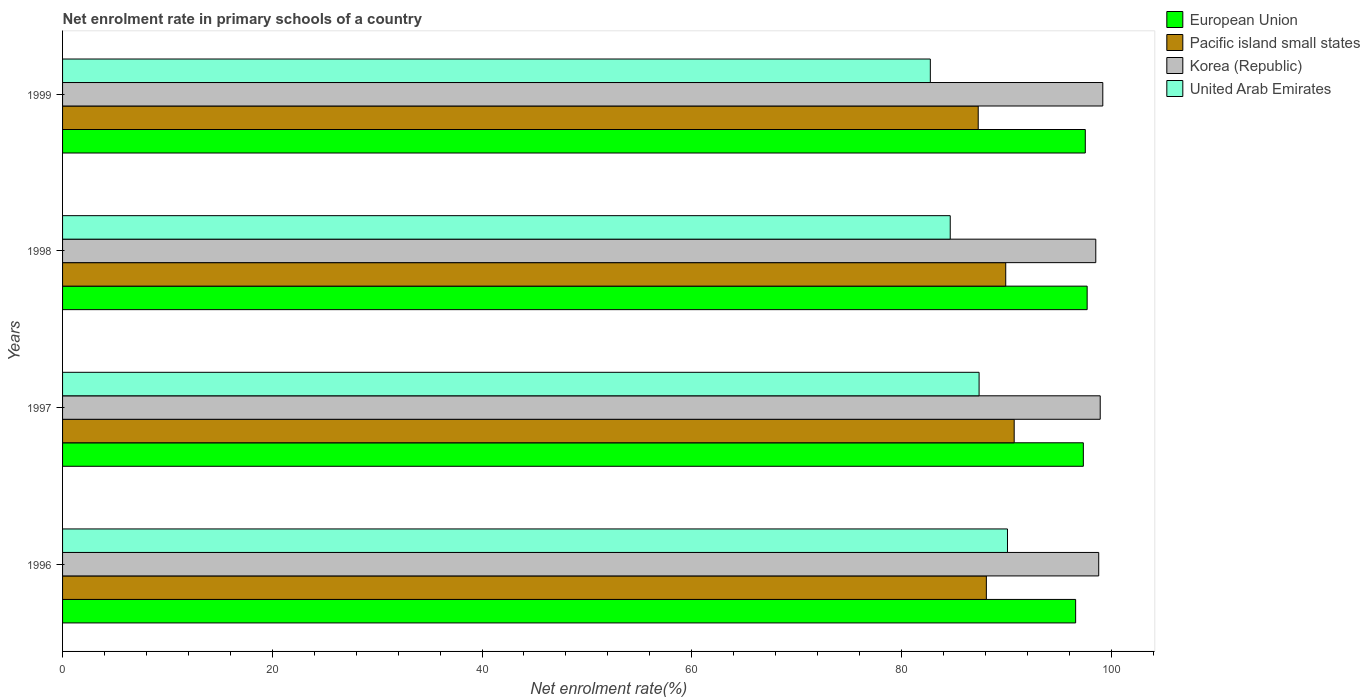How many groups of bars are there?
Ensure brevity in your answer.  4. How many bars are there on the 2nd tick from the bottom?
Give a very brief answer. 4. What is the net enrolment rate in primary schools in Korea (Republic) in 1999?
Keep it short and to the point. 99.19. Across all years, what is the maximum net enrolment rate in primary schools in European Union?
Your response must be concise. 97.7. Across all years, what is the minimum net enrolment rate in primary schools in Pacific island small states?
Provide a short and direct response. 87.32. In which year was the net enrolment rate in primary schools in United Arab Emirates minimum?
Your answer should be very brief. 1999. What is the total net enrolment rate in primary schools in Pacific island small states in the graph?
Provide a succinct answer. 356.09. What is the difference between the net enrolment rate in primary schools in United Arab Emirates in 1998 and that in 1999?
Provide a succinct answer. 1.9. What is the difference between the net enrolment rate in primary schools in United Arab Emirates in 1998 and the net enrolment rate in primary schools in Korea (Republic) in 1999?
Ensure brevity in your answer.  -14.55. What is the average net enrolment rate in primary schools in Korea (Republic) per year?
Your response must be concise. 98.87. In the year 1996, what is the difference between the net enrolment rate in primary schools in United Arab Emirates and net enrolment rate in primary schools in European Union?
Offer a very short reply. -6.5. What is the ratio of the net enrolment rate in primary schools in United Arab Emirates in 1996 to that in 1999?
Offer a terse response. 1.09. What is the difference between the highest and the second highest net enrolment rate in primary schools in Korea (Republic)?
Make the answer very short. 0.25. What is the difference between the highest and the lowest net enrolment rate in primary schools in Korea (Republic)?
Your answer should be very brief. 0.67. In how many years, is the net enrolment rate in primary schools in United Arab Emirates greater than the average net enrolment rate in primary schools in United Arab Emirates taken over all years?
Make the answer very short. 2. Is it the case that in every year, the sum of the net enrolment rate in primary schools in United Arab Emirates and net enrolment rate in primary schools in Pacific island small states is greater than the sum of net enrolment rate in primary schools in European Union and net enrolment rate in primary schools in Korea (Republic)?
Provide a succinct answer. No. What does the 4th bar from the top in 1996 represents?
Offer a very short reply. European Union. What does the 2nd bar from the bottom in 1999 represents?
Your answer should be very brief. Pacific island small states. How many bars are there?
Your answer should be very brief. 16. Are the values on the major ticks of X-axis written in scientific E-notation?
Give a very brief answer. No. How many legend labels are there?
Offer a very short reply. 4. What is the title of the graph?
Offer a very short reply. Net enrolment rate in primary schools of a country. Does "Central African Republic" appear as one of the legend labels in the graph?
Your answer should be compact. No. What is the label or title of the X-axis?
Your answer should be very brief. Net enrolment rate(%). What is the Net enrolment rate(%) in European Union in 1996?
Make the answer very short. 96.6. What is the Net enrolment rate(%) of Pacific island small states in 1996?
Keep it short and to the point. 88.09. What is the Net enrolment rate(%) in Korea (Republic) in 1996?
Ensure brevity in your answer.  98.8. What is the Net enrolment rate(%) of United Arab Emirates in 1996?
Your response must be concise. 90.11. What is the Net enrolment rate(%) in European Union in 1997?
Make the answer very short. 97.34. What is the Net enrolment rate(%) of Pacific island small states in 1997?
Your answer should be very brief. 90.74. What is the Net enrolment rate(%) of Korea (Republic) in 1997?
Ensure brevity in your answer.  98.95. What is the Net enrolment rate(%) of United Arab Emirates in 1997?
Offer a very short reply. 87.4. What is the Net enrolment rate(%) in European Union in 1998?
Make the answer very short. 97.7. What is the Net enrolment rate(%) of Pacific island small states in 1998?
Your answer should be compact. 89.94. What is the Net enrolment rate(%) of Korea (Republic) in 1998?
Provide a succinct answer. 98.52. What is the Net enrolment rate(%) in United Arab Emirates in 1998?
Give a very brief answer. 84.65. What is the Net enrolment rate(%) of European Union in 1999?
Provide a short and direct response. 97.52. What is the Net enrolment rate(%) in Pacific island small states in 1999?
Keep it short and to the point. 87.32. What is the Net enrolment rate(%) in Korea (Republic) in 1999?
Your response must be concise. 99.19. What is the Net enrolment rate(%) of United Arab Emirates in 1999?
Your answer should be compact. 82.75. Across all years, what is the maximum Net enrolment rate(%) in European Union?
Offer a terse response. 97.7. Across all years, what is the maximum Net enrolment rate(%) of Pacific island small states?
Offer a very short reply. 90.74. Across all years, what is the maximum Net enrolment rate(%) of Korea (Republic)?
Provide a short and direct response. 99.19. Across all years, what is the maximum Net enrolment rate(%) of United Arab Emirates?
Make the answer very short. 90.11. Across all years, what is the minimum Net enrolment rate(%) in European Union?
Your answer should be very brief. 96.6. Across all years, what is the minimum Net enrolment rate(%) in Pacific island small states?
Your answer should be very brief. 87.32. Across all years, what is the minimum Net enrolment rate(%) in Korea (Republic)?
Offer a very short reply. 98.52. Across all years, what is the minimum Net enrolment rate(%) in United Arab Emirates?
Your answer should be compact. 82.75. What is the total Net enrolment rate(%) of European Union in the graph?
Provide a succinct answer. 389.17. What is the total Net enrolment rate(%) of Pacific island small states in the graph?
Offer a terse response. 356.09. What is the total Net enrolment rate(%) in Korea (Republic) in the graph?
Give a very brief answer. 395.47. What is the total Net enrolment rate(%) of United Arab Emirates in the graph?
Give a very brief answer. 344.9. What is the difference between the Net enrolment rate(%) of European Union in 1996 and that in 1997?
Ensure brevity in your answer.  -0.74. What is the difference between the Net enrolment rate(%) of Pacific island small states in 1996 and that in 1997?
Make the answer very short. -2.65. What is the difference between the Net enrolment rate(%) of Korea (Republic) in 1996 and that in 1997?
Provide a short and direct response. -0.14. What is the difference between the Net enrolment rate(%) of United Arab Emirates in 1996 and that in 1997?
Provide a short and direct response. 2.71. What is the difference between the Net enrolment rate(%) in European Union in 1996 and that in 1998?
Your answer should be compact. -1.1. What is the difference between the Net enrolment rate(%) of Pacific island small states in 1996 and that in 1998?
Offer a very short reply. -1.85. What is the difference between the Net enrolment rate(%) in Korea (Republic) in 1996 and that in 1998?
Make the answer very short. 0.28. What is the difference between the Net enrolment rate(%) of United Arab Emirates in 1996 and that in 1998?
Make the answer very short. 5.46. What is the difference between the Net enrolment rate(%) in European Union in 1996 and that in 1999?
Provide a succinct answer. -0.92. What is the difference between the Net enrolment rate(%) in Pacific island small states in 1996 and that in 1999?
Offer a very short reply. 0.78. What is the difference between the Net enrolment rate(%) of Korea (Republic) in 1996 and that in 1999?
Provide a short and direct response. -0.39. What is the difference between the Net enrolment rate(%) in United Arab Emirates in 1996 and that in 1999?
Offer a very short reply. 7.36. What is the difference between the Net enrolment rate(%) of European Union in 1997 and that in 1998?
Your answer should be compact. -0.36. What is the difference between the Net enrolment rate(%) in Pacific island small states in 1997 and that in 1998?
Offer a very short reply. 0.8. What is the difference between the Net enrolment rate(%) in Korea (Republic) in 1997 and that in 1998?
Keep it short and to the point. 0.42. What is the difference between the Net enrolment rate(%) of United Arab Emirates in 1997 and that in 1998?
Keep it short and to the point. 2.75. What is the difference between the Net enrolment rate(%) of European Union in 1997 and that in 1999?
Make the answer very short. -0.19. What is the difference between the Net enrolment rate(%) in Pacific island small states in 1997 and that in 1999?
Keep it short and to the point. 3.43. What is the difference between the Net enrolment rate(%) in Korea (Republic) in 1997 and that in 1999?
Make the answer very short. -0.25. What is the difference between the Net enrolment rate(%) of United Arab Emirates in 1997 and that in 1999?
Keep it short and to the point. 4.65. What is the difference between the Net enrolment rate(%) in European Union in 1998 and that in 1999?
Your response must be concise. 0.18. What is the difference between the Net enrolment rate(%) in Pacific island small states in 1998 and that in 1999?
Provide a short and direct response. 2.62. What is the difference between the Net enrolment rate(%) in Korea (Republic) in 1998 and that in 1999?
Offer a terse response. -0.67. What is the difference between the Net enrolment rate(%) of United Arab Emirates in 1998 and that in 1999?
Give a very brief answer. 1.9. What is the difference between the Net enrolment rate(%) of European Union in 1996 and the Net enrolment rate(%) of Pacific island small states in 1997?
Keep it short and to the point. 5.86. What is the difference between the Net enrolment rate(%) in European Union in 1996 and the Net enrolment rate(%) in Korea (Republic) in 1997?
Your answer should be compact. -2.34. What is the difference between the Net enrolment rate(%) of European Union in 1996 and the Net enrolment rate(%) of United Arab Emirates in 1997?
Your answer should be very brief. 9.21. What is the difference between the Net enrolment rate(%) of Pacific island small states in 1996 and the Net enrolment rate(%) of Korea (Republic) in 1997?
Your response must be concise. -10.86. What is the difference between the Net enrolment rate(%) in Pacific island small states in 1996 and the Net enrolment rate(%) in United Arab Emirates in 1997?
Your answer should be very brief. 0.69. What is the difference between the Net enrolment rate(%) of Korea (Republic) in 1996 and the Net enrolment rate(%) of United Arab Emirates in 1997?
Offer a terse response. 11.41. What is the difference between the Net enrolment rate(%) in European Union in 1996 and the Net enrolment rate(%) in Pacific island small states in 1998?
Make the answer very short. 6.66. What is the difference between the Net enrolment rate(%) of European Union in 1996 and the Net enrolment rate(%) of Korea (Republic) in 1998?
Keep it short and to the point. -1.92. What is the difference between the Net enrolment rate(%) of European Union in 1996 and the Net enrolment rate(%) of United Arab Emirates in 1998?
Offer a very short reply. 11.96. What is the difference between the Net enrolment rate(%) of Pacific island small states in 1996 and the Net enrolment rate(%) of Korea (Republic) in 1998?
Give a very brief answer. -10.43. What is the difference between the Net enrolment rate(%) of Pacific island small states in 1996 and the Net enrolment rate(%) of United Arab Emirates in 1998?
Your answer should be compact. 3.45. What is the difference between the Net enrolment rate(%) in Korea (Republic) in 1996 and the Net enrolment rate(%) in United Arab Emirates in 1998?
Offer a terse response. 14.16. What is the difference between the Net enrolment rate(%) in European Union in 1996 and the Net enrolment rate(%) in Pacific island small states in 1999?
Provide a short and direct response. 9.29. What is the difference between the Net enrolment rate(%) of European Union in 1996 and the Net enrolment rate(%) of Korea (Republic) in 1999?
Ensure brevity in your answer.  -2.59. What is the difference between the Net enrolment rate(%) in European Union in 1996 and the Net enrolment rate(%) in United Arab Emirates in 1999?
Your answer should be very brief. 13.86. What is the difference between the Net enrolment rate(%) in Pacific island small states in 1996 and the Net enrolment rate(%) in Korea (Republic) in 1999?
Your answer should be very brief. -11.1. What is the difference between the Net enrolment rate(%) of Pacific island small states in 1996 and the Net enrolment rate(%) of United Arab Emirates in 1999?
Your response must be concise. 5.34. What is the difference between the Net enrolment rate(%) of Korea (Republic) in 1996 and the Net enrolment rate(%) of United Arab Emirates in 1999?
Offer a terse response. 16.06. What is the difference between the Net enrolment rate(%) in European Union in 1997 and the Net enrolment rate(%) in Pacific island small states in 1998?
Make the answer very short. 7.4. What is the difference between the Net enrolment rate(%) of European Union in 1997 and the Net enrolment rate(%) of Korea (Republic) in 1998?
Keep it short and to the point. -1.19. What is the difference between the Net enrolment rate(%) in European Union in 1997 and the Net enrolment rate(%) in United Arab Emirates in 1998?
Your answer should be very brief. 12.69. What is the difference between the Net enrolment rate(%) of Pacific island small states in 1997 and the Net enrolment rate(%) of Korea (Republic) in 1998?
Provide a succinct answer. -7.78. What is the difference between the Net enrolment rate(%) in Pacific island small states in 1997 and the Net enrolment rate(%) in United Arab Emirates in 1998?
Keep it short and to the point. 6.1. What is the difference between the Net enrolment rate(%) in Korea (Republic) in 1997 and the Net enrolment rate(%) in United Arab Emirates in 1998?
Keep it short and to the point. 14.3. What is the difference between the Net enrolment rate(%) of European Union in 1997 and the Net enrolment rate(%) of Pacific island small states in 1999?
Your response must be concise. 10.02. What is the difference between the Net enrolment rate(%) of European Union in 1997 and the Net enrolment rate(%) of Korea (Republic) in 1999?
Your answer should be very brief. -1.85. What is the difference between the Net enrolment rate(%) in European Union in 1997 and the Net enrolment rate(%) in United Arab Emirates in 1999?
Your response must be concise. 14.59. What is the difference between the Net enrolment rate(%) in Pacific island small states in 1997 and the Net enrolment rate(%) in Korea (Republic) in 1999?
Give a very brief answer. -8.45. What is the difference between the Net enrolment rate(%) of Pacific island small states in 1997 and the Net enrolment rate(%) of United Arab Emirates in 1999?
Make the answer very short. 8. What is the difference between the Net enrolment rate(%) of Korea (Republic) in 1997 and the Net enrolment rate(%) of United Arab Emirates in 1999?
Your response must be concise. 16.2. What is the difference between the Net enrolment rate(%) in European Union in 1998 and the Net enrolment rate(%) in Pacific island small states in 1999?
Provide a short and direct response. 10.39. What is the difference between the Net enrolment rate(%) of European Union in 1998 and the Net enrolment rate(%) of Korea (Republic) in 1999?
Your answer should be compact. -1.49. What is the difference between the Net enrolment rate(%) of European Union in 1998 and the Net enrolment rate(%) of United Arab Emirates in 1999?
Offer a terse response. 14.96. What is the difference between the Net enrolment rate(%) of Pacific island small states in 1998 and the Net enrolment rate(%) of Korea (Republic) in 1999?
Your response must be concise. -9.25. What is the difference between the Net enrolment rate(%) in Pacific island small states in 1998 and the Net enrolment rate(%) in United Arab Emirates in 1999?
Offer a terse response. 7.19. What is the difference between the Net enrolment rate(%) of Korea (Republic) in 1998 and the Net enrolment rate(%) of United Arab Emirates in 1999?
Your answer should be very brief. 15.78. What is the average Net enrolment rate(%) of European Union per year?
Make the answer very short. 97.29. What is the average Net enrolment rate(%) in Pacific island small states per year?
Provide a succinct answer. 89.02. What is the average Net enrolment rate(%) in Korea (Republic) per year?
Provide a short and direct response. 98.87. What is the average Net enrolment rate(%) in United Arab Emirates per year?
Make the answer very short. 86.22. In the year 1996, what is the difference between the Net enrolment rate(%) in European Union and Net enrolment rate(%) in Pacific island small states?
Offer a very short reply. 8.51. In the year 1996, what is the difference between the Net enrolment rate(%) in European Union and Net enrolment rate(%) in Korea (Republic)?
Keep it short and to the point. -2.2. In the year 1996, what is the difference between the Net enrolment rate(%) of European Union and Net enrolment rate(%) of United Arab Emirates?
Your answer should be compact. 6.5. In the year 1996, what is the difference between the Net enrolment rate(%) in Pacific island small states and Net enrolment rate(%) in Korea (Republic)?
Provide a short and direct response. -10.71. In the year 1996, what is the difference between the Net enrolment rate(%) in Pacific island small states and Net enrolment rate(%) in United Arab Emirates?
Provide a short and direct response. -2.01. In the year 1996, what is the difference between the Net enrolment rate(%) in Korea (Republic) and Net enrolment rate(%) in United Arab Emirates?
Offer a terse response. 8.7. In the year 1997, what is the difference between the Net enrolment rate(%) of European Union and Net enrolment rate(%) of Pacific island small states?
Your answer should be very brief. 6.6. In the year 1997, what is the difference between the Net enrolment rate(%) of European Union and Net enrolment rate(%) of Korea (Republic)?
Your response must be concise. -1.61. In the year 1997, what is the difference between the Net enrolment rate(%) of European Union and Net enrolment rate(%) of United Arab Emirates?
Make the answer very short. 9.94. In the year 1997, what is the difference between the Net enrolment rate(%) in Pacific island small states and Net enrolment rate(%) in Korea (Republic)?
Offer a very short reply. -8.2. In the year 1997, what is the difference between the Net enrolment rate(%) in Pacific island small states and Net enrolment rate(%) in United Arab Emirates?
Your answer should be compact. 3.35. In the year 1997, what is the difference between the Net enrolment rate(%) of Korea (Republic) and Net enrolment rate(%) of United Arab Emirates?
Provide a short and direct response. 11.55. In the year 1998, what is the difference between the Net enrolment rate(%) in European Union and Net enrolment rate(%) in Pacific island small states?
Your answer should be compact. 7.76. In the year 1998, what is the difference between the Net enrolment rate(%) in European Union and Net enrolment rate(%) in Korea (Republic)?
Your response must be concise. -0.82. In the year 1998, what is the difference between the Net enrolment rate(%) of European Union and Net enrolment rate(%) of United Arab Emirates?
Make the answer very short. 13.06. In the year 1998, what is the difference between the Net enrolment rate(%) of Pacific island small states and Net enrolment rate(%) of Korea (Republic)?
Your answer should be very brief. -8.59. In the year 1998, what is the difference between the Net enrolment rate(%) in Pacific island small states and Net enrolment rate(%) in United Arab Emirates?
Offer a very short reply. 5.29. In the year 1998, what is the difference between the Net enrolment rate(%) of Korea (Republic) and Net enrolment rate(%) of United Arab Emirates?
Your answer should be very brief. 13.88. In the year 1999, what is the difference between the Net enrolment rate(%) in European Union and Net enrolment rate(%) in Pacific island small states?
Your answer should be compact. 10.21. In the year 1999, what is the difference between the Net enrolment rate(%) of European Union and Net enrolment rate(%) of Korea (Republic)?
Your response must be concise. -1.67. In the year 1999, what is the difference between the Net enrolment rate(%) in European Union and Net enrolment rate(%) in United Arab Emirates?
Offer a very short reply. 14.78. In the year 1999, what is the difference between the Net enrolment rate(%) in Pacific island small states and Net enrolment rate(%) in Korea (Republic)?
Your answer should be compact. -11.88. In the year 1999, what is the difference between the Net enrolment rate(%) in Pacific island small states and Net enrolment rate(%) in United Arab Emirates?
Your response must be concise. 4.57. In the year 1999, what is the difference between the Net enrolment rate(%) of Korea (Republic) and Net enrolment rate(%) of United Arab Emirates?
Your answer should be very brief. 16.45. What is the ratio of the Net enrolment rate(%) in European Union in 1996 to that in 1997?
Provide a short and direct response. 0.99. What is the ratio of the Net enrolment rate(%) in Pacific island small states in 1996 to that in 1997?
Your answer should be compact. 0.97. What is the ratio of the Net enrolment rate(%) of Korea (Republic) in 1996 to that in 1997?
Your response must be concise. 1. What is the ratio of the Net enrolment rate(%) of United Arab Emirates in 1996 to that in 1997?
Your response must be concise. 1.03. What is the ratio of the Net enrolment rate(%) of European Union in 1996 to that in 1998?
Give a very brief answer. 0.99. What is the ratio of the Net enrolment rate(%) of Pacific island small states in 1996 to that in 1998?
Give a very brief answer. 0.98. What is the ratio of the Net enrolment rate(%) of Korea (Republic) in 1996 to that in 1998?
Your response must be concise. 1. What is the ratio of the Net enrolment rate(%) in United Arab Emirates in 1996 to that in 1998?
Offer a terse response. 1.06. What is the ratio of the Net enrolment rate(%) in European Union in 1996 to that in 1999?
Your answer should be compact. 0.99. What is the ratio of the Net enrolment rate(%) in Pacific island small states in 1996 to that in 1999?
Give a very brief answer. 1.01. What is the ratio of the Net enrolment rate(%) in Korea (Republic) in 1996 to that in 1999?
Your answer should be very brief. 1. What is the ratio of the Net enrolment rate(%) of United Arab Emirates in 1996 to that in 1999?
Your response must be concise. 1.09. What is the ratio of the Net enrolment rate(%) of Pacific island small states in 1997 to that in 1998?
Keep it short and to the point. 1.01. What is the ratio of the Net enrolment rate(%) of Korea (Republic) in 1997 to that in 1998?
Ensure brevity in your answer.  1. What is the ratio of the Net enrolment rate(%) of United Arab Emirates in 1997 to that in 1998?
Make the answer very short. 1.03. What is the ratio of the Net enrolment rate(%) of European Union in 1997 to that in 1999?
Make the answer very short. 1. What is the ratio of the Net enrolment rate(%) of Pacific island small states in 1997 to that in 1999?
Your answer should be compact. 1.04. What is the ratio of the Net enrolment rate(%) in Korea (Republic) in 1997 to that in 1999?
Provide a short and direct response. 1. What is the ratio of the Net enrolment rate(%) of United Arab Emirates in 1997 to that in 1999?
Your answer should be compact. 1.06. What is the ratio of the Net enrolment rate(%) of Korea (Republic) in 1998 to that in 1999?
Your response must be concise. 0.99. What is the ratio of the Net enrolment rate(%) of United Arab Emirates in 1998 to that in 1999?
Provide a succinct answer. 1.02. What is the difference between the highest and the second highest Net enrolment rate(%) of European Union?
Give a very brief answer. 0.18. What is the difference between the highest and the second highest Net enrolment rate(%) of Pacific island small states?
Your answer should be very brief. 0.8. What is the difference between the highest and the second highest Net enrolment rate(%) of Korea (Republic)?
Your answer should be very brief. 0.25. What is the difference between the highest and the second highest Net enrolment rate(%) in United Arab Emirates?
Your response must be concise. 2.71. What is the difference between the highest and the lowest Net enrolment rate(%) of European Union?
Provide a short and direct response. 1.1. What is the difference between the highest and the lowest Net enrolment rate(%) of Pacific island small states?
Give a very brief answer. 3.43. What is the difference between the highest and the lowest Net enrolment rate(%) in Korea (Republic)?
Offer a terse response. 0.67. What is the difference between the highest and the lowest Net enrolment rate(%) in United Arab Emirates?
Give a very brief answer. 7.36. 